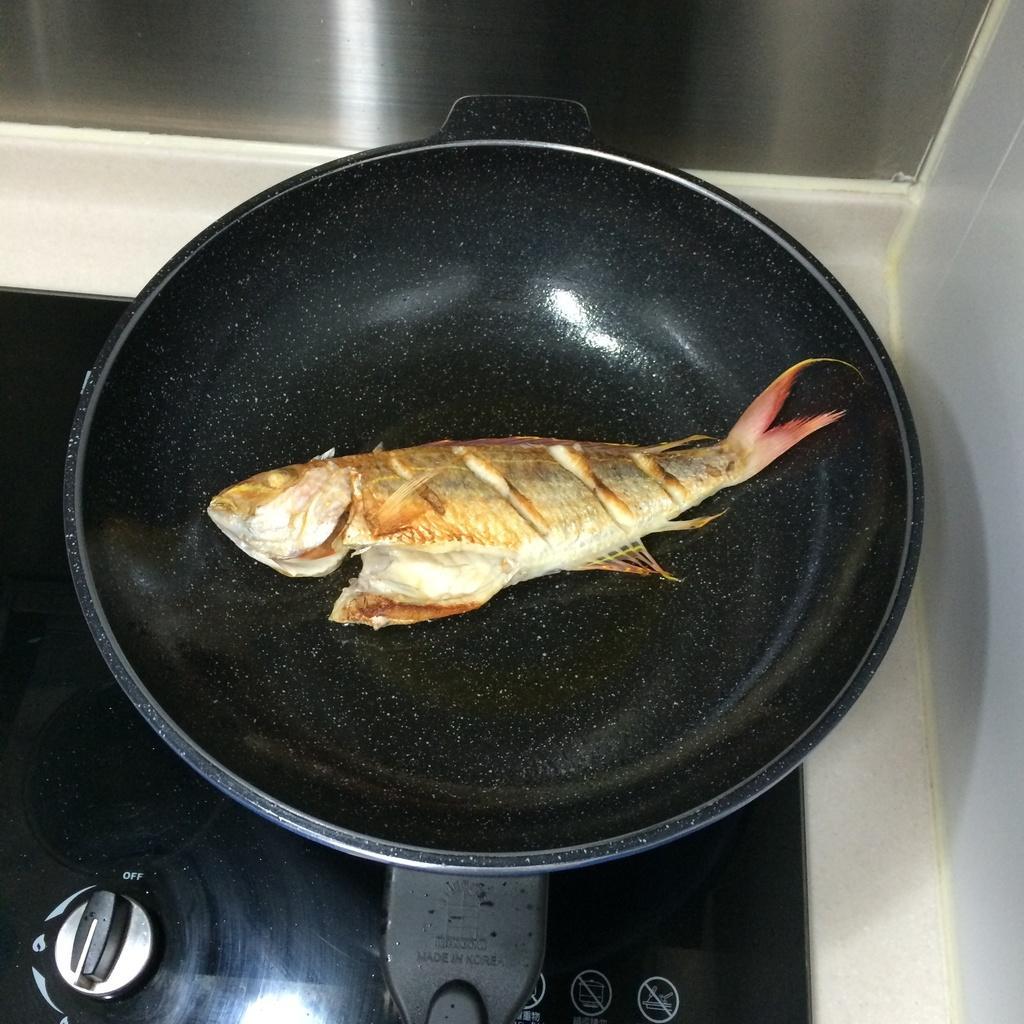In one or two sentences, can you explain what this image depicts? In this image, I can see a fish in the pan ,and the pan is on the stove. 